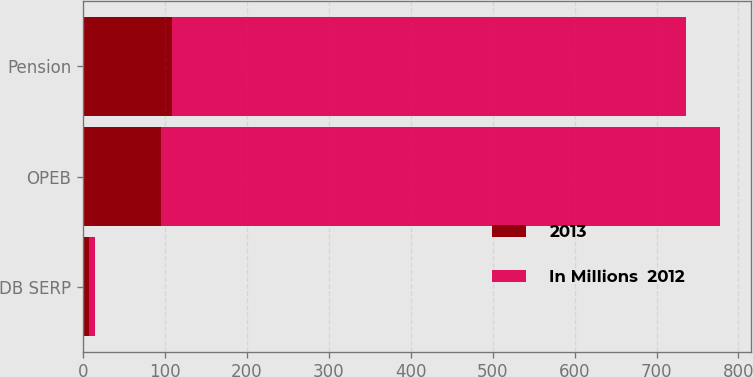<chart> <loc_0><loc_0><loc_500><loc_500><stacked_bar_chart><ecel><fcel>DB SERP<fcel>OPEB<fcel>Pension<nl><fcel>2013<fcel>8<fcel>95<fcel>109<nl><fcel>In Millions  2012<fcel>7<fcel>682<fcel>627<nl></chart> 